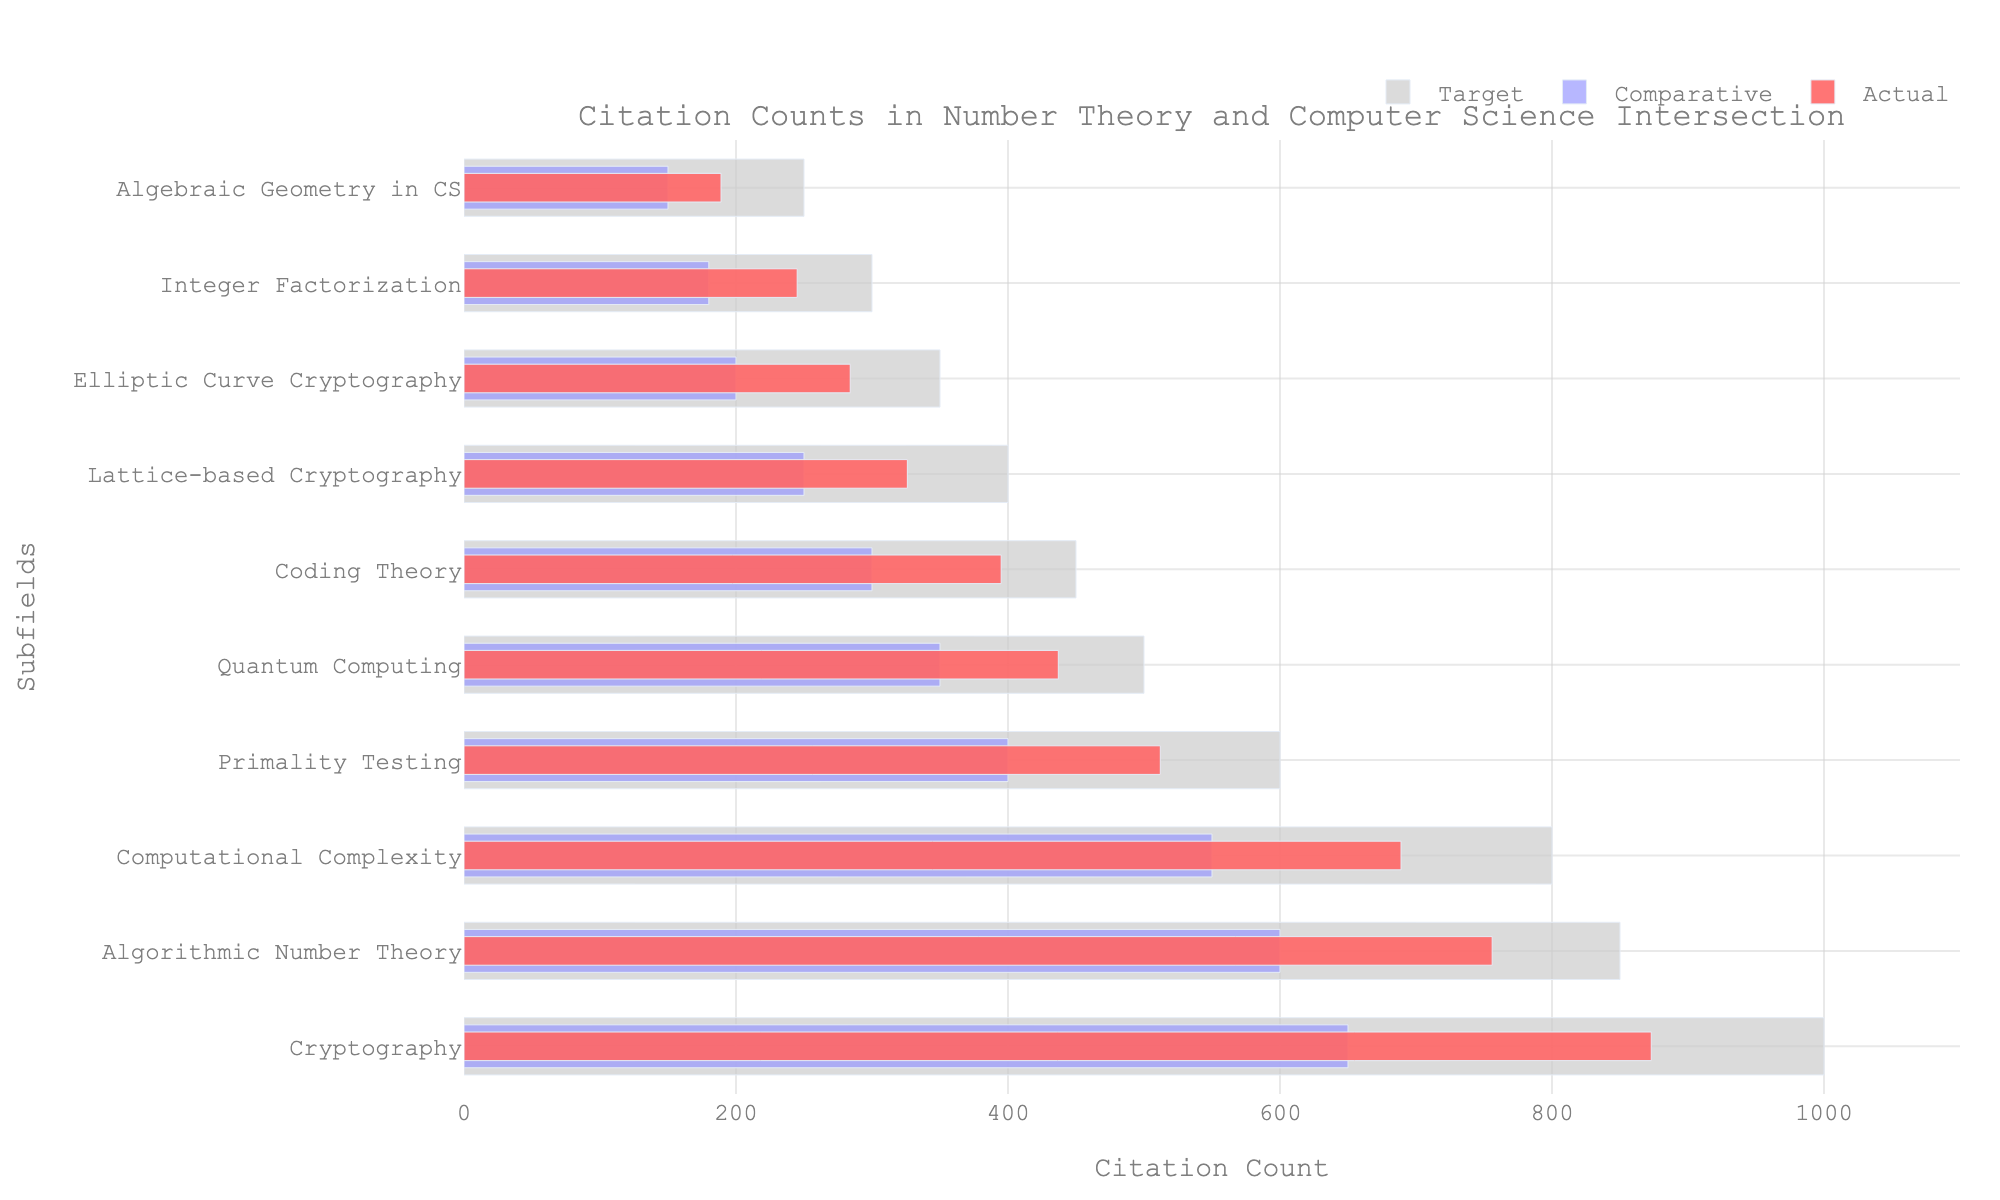How many subfields are represented in the figure? Count the number of different subfields listed on the y-axis. There are 10 different subfields.
Answer: 10 Which subfield has the highest actual citation count? Look for the subfield with the largest bar in the 'Actual' category. Cryptography has the highest actual citation count with 873 citations.
Answer: Cryptography What is the target citation count for Quantum Computing? Identify the bar for 'Quantum Computing' and note the length of the 'Target' bar. The target citation count for Quantum Computing is 500.
Answer: 500 Which subfield is closest to meeting its target citation count? Compare the 'Actual' citation count with the 'Target' citation count for each subfield and find the smallest difference. Algorithmic Number Theory is closest, with an actual count of 756 and a target of 850, a difference of 94.
Answer: Algorithmic Number Theory How does the actual citation count for Integer Factorization compare to its target citation count? Find the 'Actual' and 'Target' citations for Integer Factorization and compute the difference. Integer Factorization has an actual count of 245 and a target of 300, which is 55 less.
Answer: 55 less Which subfield has the lowest comparative citation count? Look for the subfield with the shortest bar in the 'Comparative' category. Algebraic Geometry in CS has the lowest comparative citation count with 150 citations.
Answer: Algebraic Geometry in CS Rank the subfields in descending order by their actual citation counts. Order the subfields from the highest to the lowest based on the 'Actual' citation count values. The order is: Cryptography, Algorithmic Number Theory, Computational Complexity, Primality Testing, Quantum Computing, Coding Theory, Lattice-based Cryptography, Elliptic Curve Cryptography, Integer Factorization, Algebraic Geometry in CS.
Answer: Cryptography, Algorithmic Number Theory, Computational Complexity, Primality Testing, Quantum Computing, Coding Theory, Lattice-based Cryptography, Elliptic Curve Cryptography, Integer Factorization, Algebraic Geometry in CS What is the average target citation count across all subfields? Sum all target citation counts and divide by the number of subfields: (1000 + 850 + 800 + 600 + 500 + 450 + 400 + 350 + 300 + 250) / 10 = 550.
Answer: 550 Which subfield shows the largest gap between actual and comparative citation counts? Compute the difference between actual and comparative citation counts for each subfield and find the maximum. Cryptography shows the largest gap with 873 actual and 650 comparative, a gap of 223.
Answer: Cryptography 